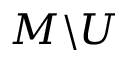<formula> <loc_0><loc_0><loc_500><loc_500>M \ U</formula> 